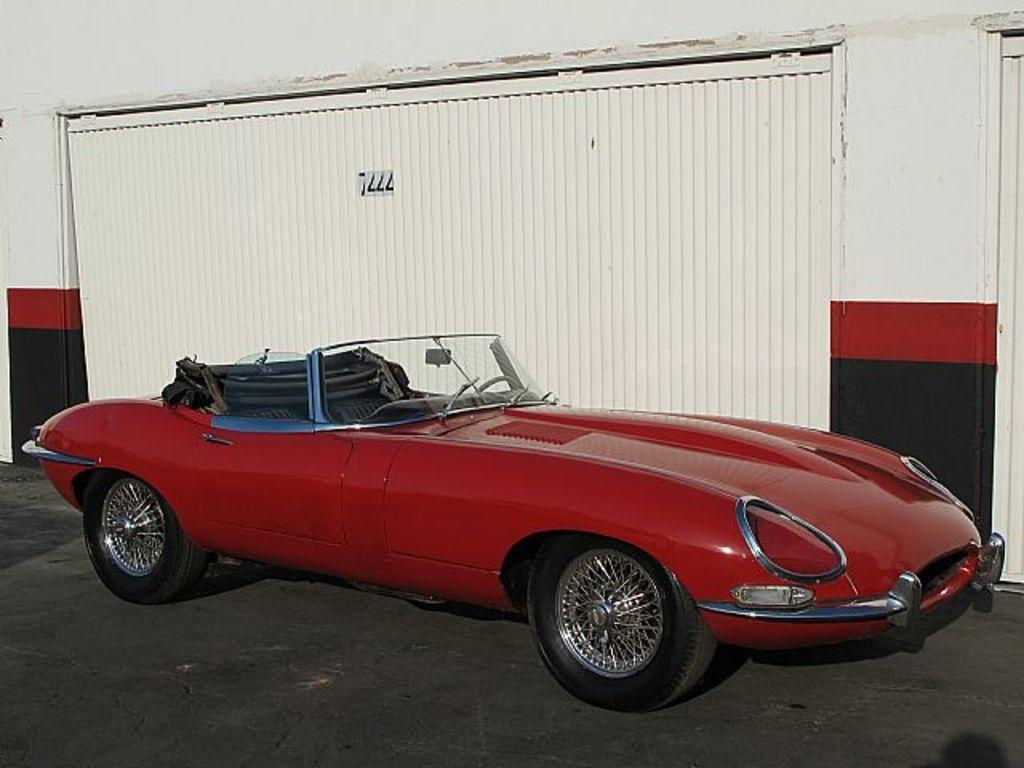What color is the car in the image? The car in the image is red. Where is the car located in the image? The car is on the road in the image. What can be seen in the background of the image? There is a wall and a shutter in the background of the image. How many apples are hanging from the shutter in the image? There are no apples present in the image, and therefore no apples can be seen hanging from the shutter. 